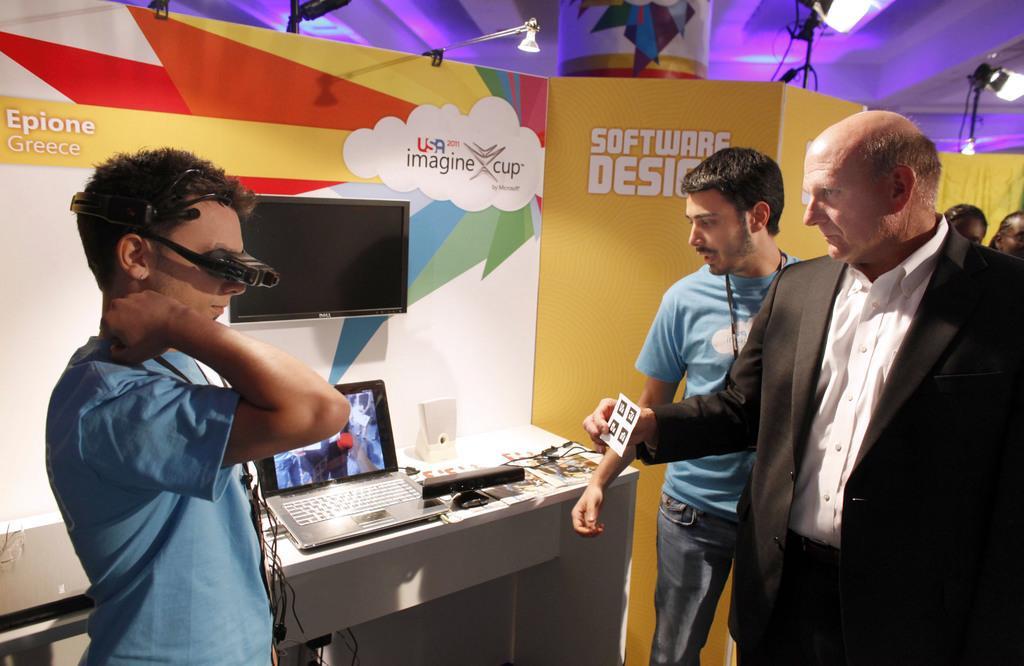Describe this image in one or two sentences. In this picture we can see a group of people standing and looking at laptop on table and we have some wires and papers on that table and in background we can see wall with television, lights, stands. 